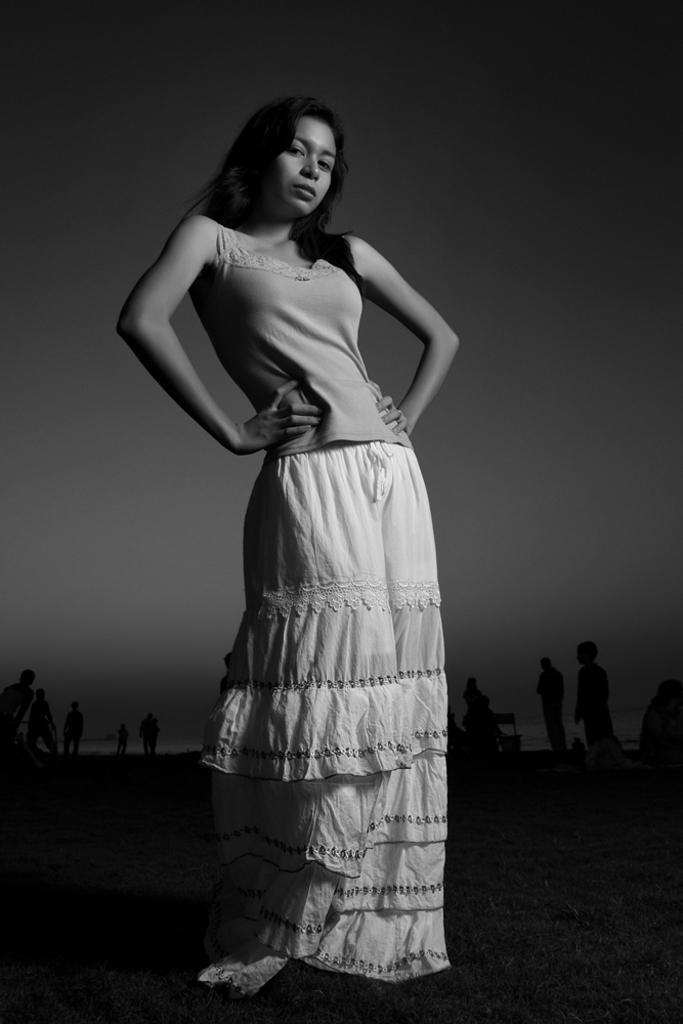In one or two sentences, can you explain what this image depicts? This is a black and white image. In this image we can see a woman standing on the ground. In the background there are people standing on the ground and sky. 